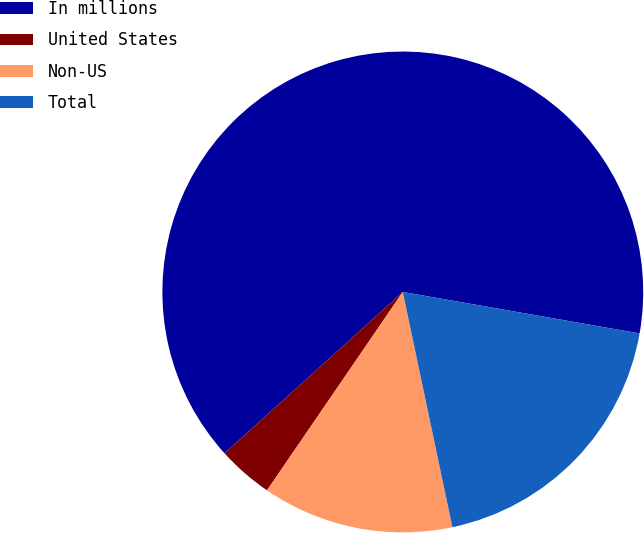Convert chart to OTSL. <chart><loc_0><loc_0><loc_500><loc_500><pie_chart><fcel>In millions<fcel>United States<fcel>Non-US<fcel>Total<nl><fcel>64.46%<fcel>3.74%<fcel>12.86%<fcel>18.93%<nl></chart> 